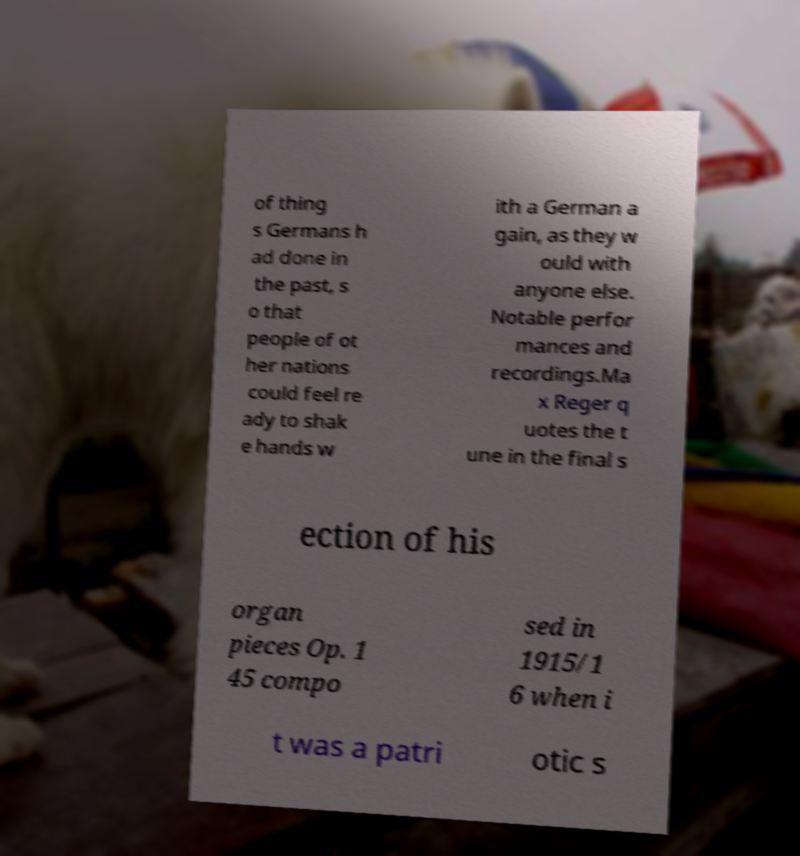I need the written content from this picture converted into text. Can you do that? of thing s Germans h ad done in the past, s o that people of ot her nations could feel re ady to shak e hands w ith a German a gain, as they w ould with anyone else. Notable perfor mances and recordings.Ma x Reger q uotes the t une in the final s ection of his organ pieces Op. 1 45 compo sed in 1915/1 6 when i t was a patri otic s 